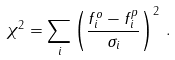<formula> <loc_0><loc_0><loc_500><loc_500>\chi ^ { 2 } = \sum _ { i } \left ( \frac { f _ { i } ^ { o } - f _ { i } ^ { p } } { \sigma _ { i } } \right ) ^ { 2 } \, .</formula> 